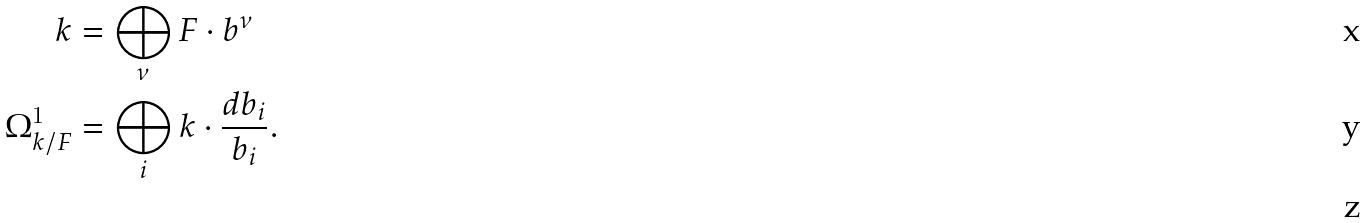<formula> <loc_0><loc_0><loc_500><loc_500>k & = \bigoplus _ { \nu } F \cdot b ^ { \nu } \\ \Omega ^ { 1 } _ { k / F } & = \bigoplus _ { i } k \cdot \frac { d b _ { i } } { b _ { i } } . \\</formula> 